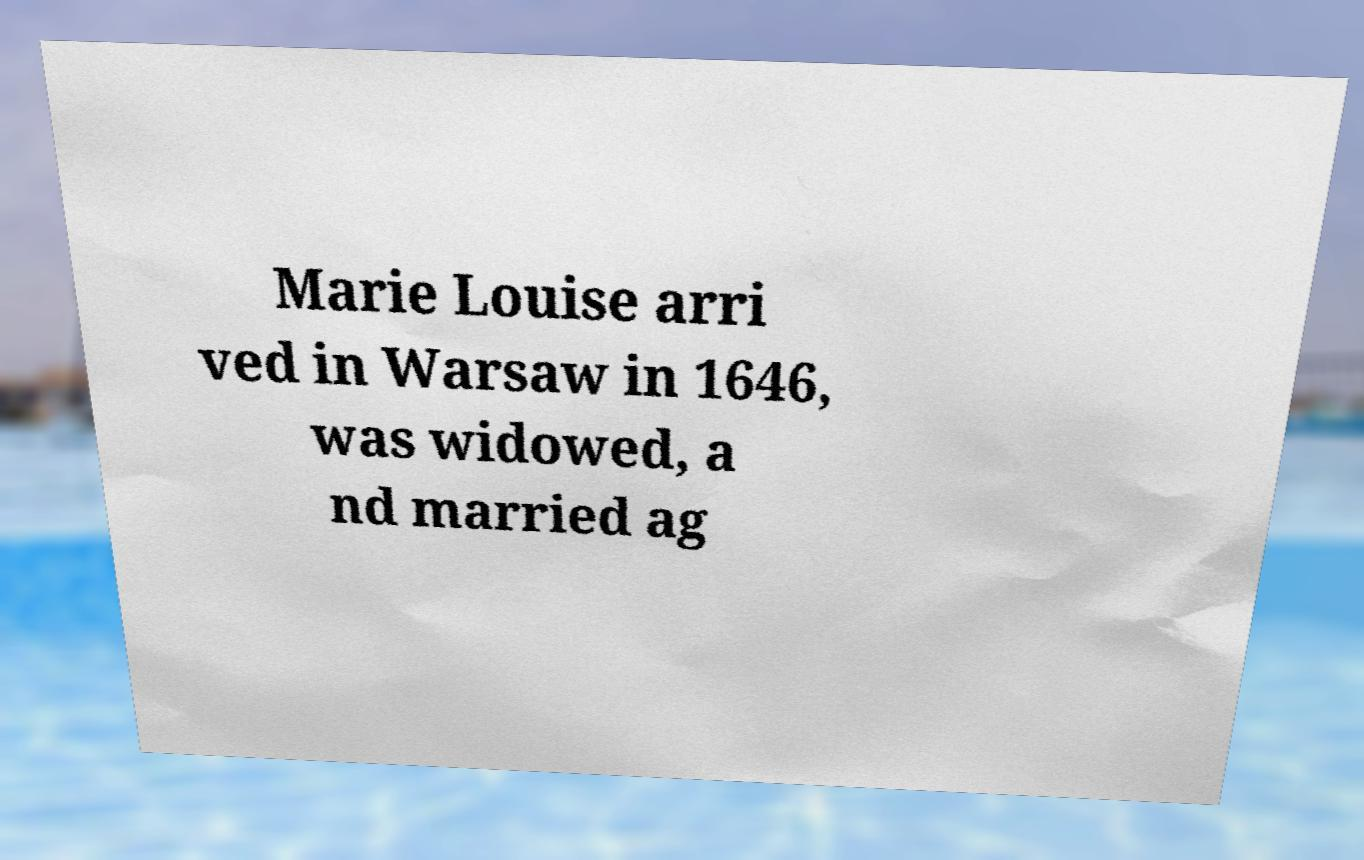I need the written content from this picture converted into text. Can you do that? Marie Louise arri ved in Warsaw in 1646, was widowed, a nd married ag 